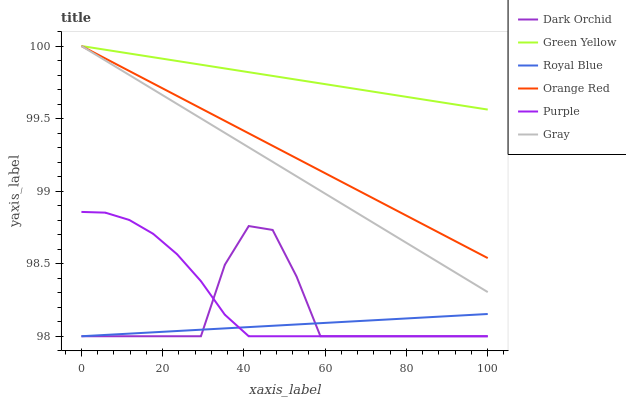Does Royal Blue have the minimum area under the curve?
Answer yes or no. Yes. Does Green Yellow have the maximum area under the curve?
Answer yes or no. Yes. Does Purple have the minimum area under the curve?
Answer yes or no. No. Does Purple have the maximum area under the curve?
Answer yes or no. No. Is Gray the smoothest?
Answer yes or no. Yes. Is Dark Orchid the roughest?
Answer yes or no. Yes. Is Purple the smoothest?
Answer yes or no. No. Is Purple the roughest?
Answer yes or no. No. Does Purple have the lowest value?
Answer yes or no. Yes. Does Green Yellow have the lowest value?
Answer yes or no. No. Does Orange Red have the highest value?
Answer yes or no. Yes. Does Purple have the highest value?
Answer yes or no. No. Is Dark Orchid less than Green Yellow?
Answer yes or no. Yes. Is Gray greater than Royal Blue?
Answer yes or no. Yes. Does Green Yellow intersect Gray?
Answer yes or no. Yes. Is Green Yellow less than Gray?
Answer yes or no. No. Is Green Yellow greater than Gray?
Answer yes or no. No. Does Dark Orchid intersect Green Yellow?
Answer yes or no. No. 